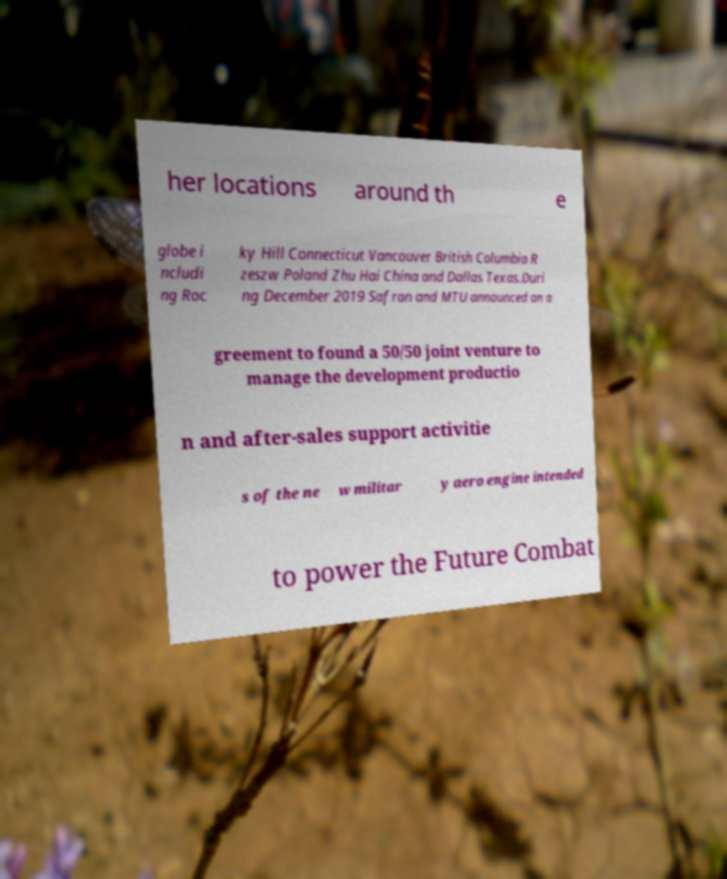What messages or text are displayed in this image? I need them in a readable, typed format. her locations around th e globe i ncludi ng Roc ky Hill Connecticut Vancouver British Columbia R zeszw Poland Zhu Hai China and Dallas Texas.Duri ng December 2019 Safran and MTU announced an a greement to found a 50/50 joint venture to manage the development productio n and after-sales support activitie s of the ne w militar y aero engine intended to power the Future Combat 